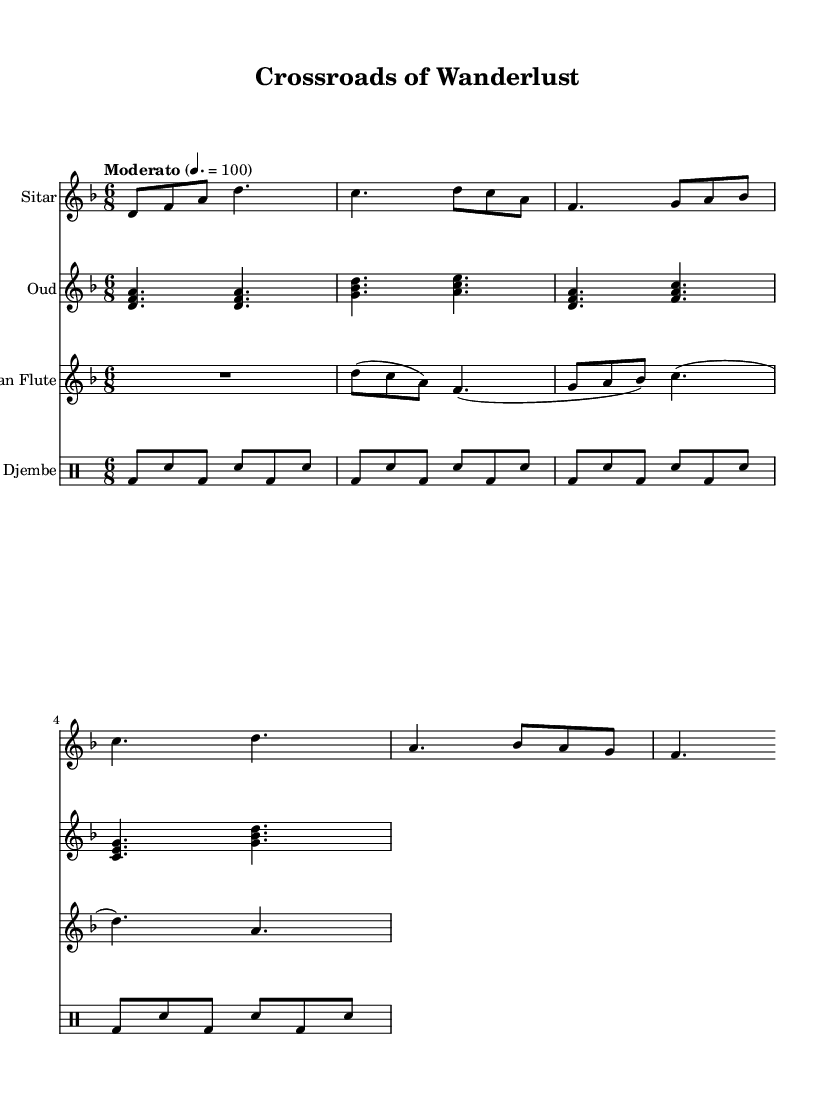What is the key signature of this music? The key signature is D minor, which has one flat (B flat). This can be identified by looking at the key signature indicated at the beginning of the music.
Answer: D minor What is the time signature of this piece? The time signature is 6/8, indicating there are six eighth notes per measure. This is shown at the beginning of the sheet music where the time is specified.
Answer: 6/8 What is the tempo marking for this piece? The tempo marking is "Moderato", and the tempo indication is 100 beats per minute (4. = 100). This is found at the beginning of the score where the tempo is explicitly noted.
Answer: Moderato Which traditional instrument has the first measure? The first measure is played by the Sitar, as it appears first in the score section dedicated to that instrument. The instrument names are specified at the start of each staff.
Answer: Sitar How many beats does the pan flute play in its first rest? The pan flute plays a rest lasting for two beats in its first measure (the rest is represented as "R2."). This can be seen in the first part of its staff notation.
Answer: 2 Which instruments are included in this fusion composition? The instruments included in this composition are Sitar, Oud, Pan Flute, and Djembe. This can be confirmed by observing all four instrument staves listed in the score.
Answer: Sitar, Oud, Pan Flute, Djembe What rhythmic pattern does the Djembe follow in its first measure? The Djembe follows a pattern of bass and snare alternating in the first measure, with a sequence of bass (bd) and snare (sn). This pattern is typical in rhythms and can be analyzed through the notated drum portions.
Answer: Bass and Snare 